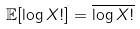Convert formula to latex. <formula><loc_0><loc_0><loc_500><loc_500>\mathbb { E } [ \log X ! ] = \overline { \log X ! }</formula> 